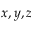<formula> <loc_0><loc_0><loc_500><loc_500>x , y , z</formula> 